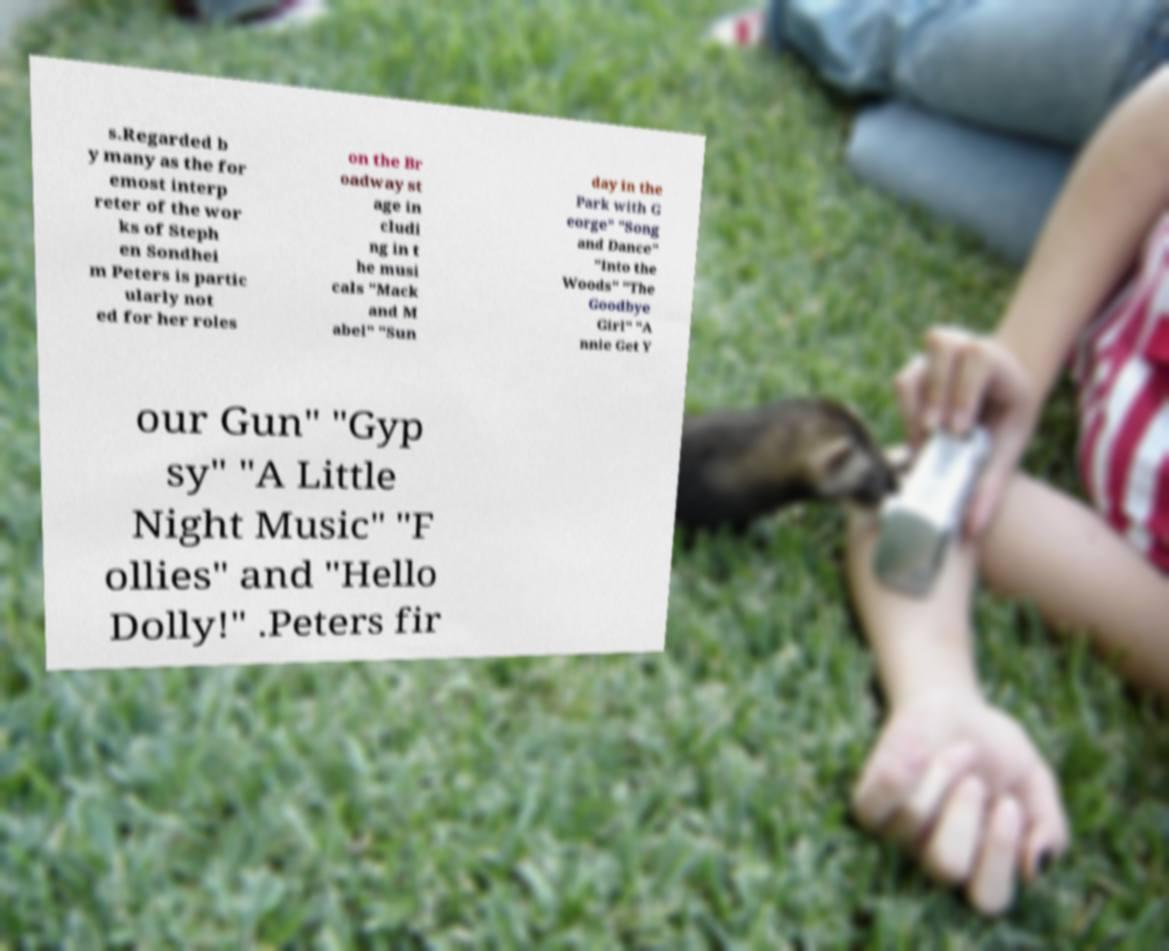Can you accurately transcribe the text from the provided image for me? s.Regarded b y many as the for emost interp reter of the wor ks of Steph en Sondhei m Peters is partic ularly not ed for her roles on the Br oadway st age in cludi ng in t he musi cals "Mack and M abel" "Sun day in the Park with G eorge" "Song and Dance" "Into the Woods" "The Goodbye Girl" "A nnie Get Y our Gun" "Gyp sy" "A Little Night Music" "F ollies" and "Hello Dolly!" .Peters fir 